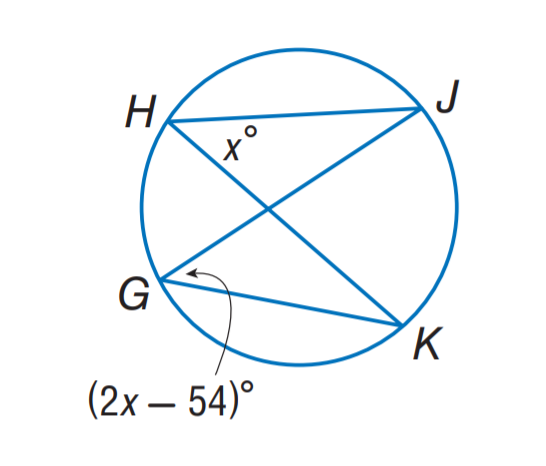Question: Find m \angle H.
Choices:
A. 40
B. 44
C. 48
D. 54
Answer with the letter. Answer: D 